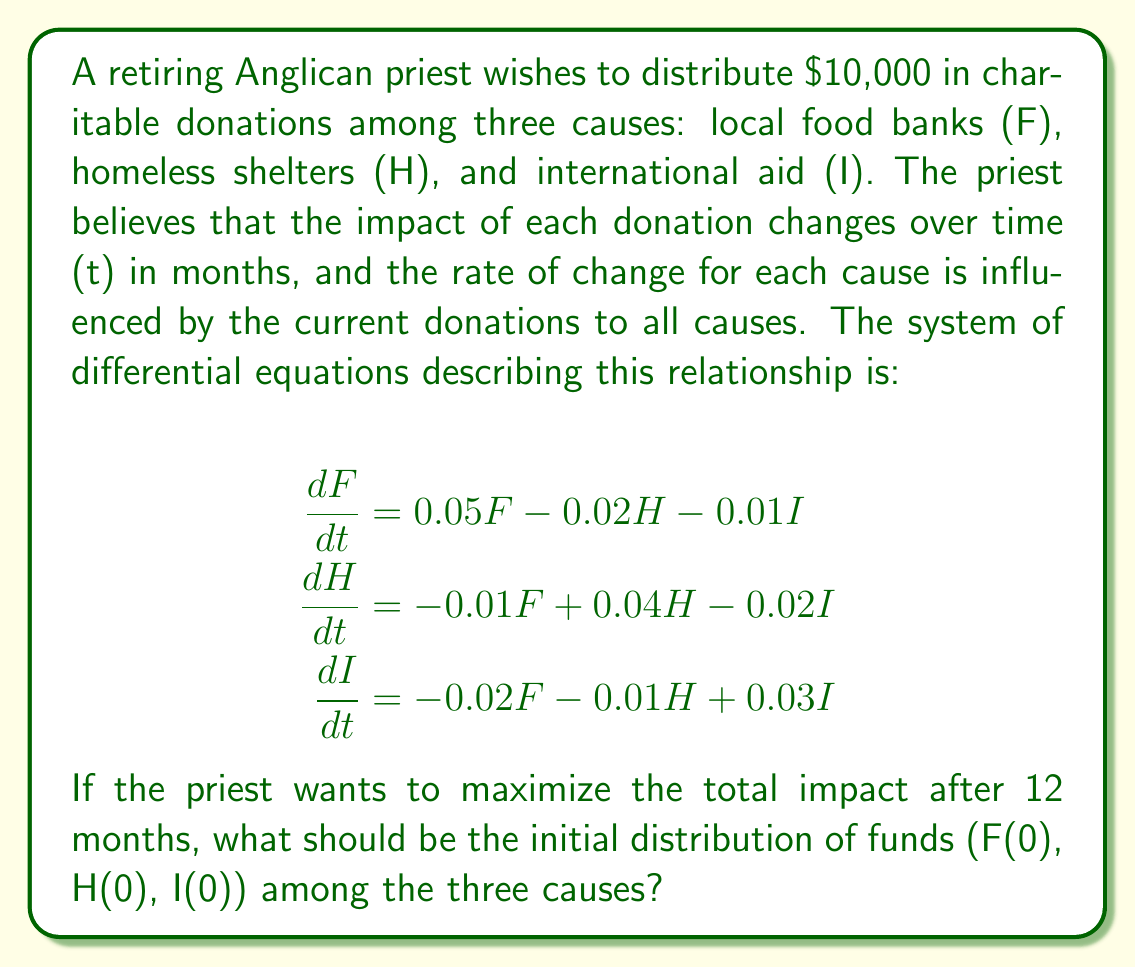Provide a solution to this math problem. To solve this problem, we need to follow these steps:

1) First, we recognize that this is a linear system of differential equations. The general solution for such a system is a linear combination of exponential functions.

2) We need to find the eigenvalues and eigenvectors of the coefficient matrix:

   $$A = \begin{bmatrix}
   0.05 & -0.02 & -0.01 \\
   -0.01 & 0.04 & -0.02 \\
   -0.02 & -0.01 & 0.03
   \end{bmatrix}$$

3) The characteristic equation is:
   
   $$det(A - \lambda I) = 0$$
   
   $$\begin{vmatrix}
   0.05-\lambda & -0.02 & -0.01 \\
   -0.01 & 0.04-\lambda & -0.02 \\
   -0.02 & -0.01 & 0.03-\lambda
   \end{vmatrix} = 0$$

4) Solving this equation gives us the eigenvalues:
   
   $\lambda_1 \approx 0.0859$, $\lambda_2 \approx 0.0256$, $\lambda_3 \approx -0.0115$

5) For each eigenvalue, we find the corresponding eigenvector. Let's call these $v_1$, $v_2$, and $v_3$.

6) The general solution is of the form:

   $$\begin{bmatrix} F(t) \\ H(t) \\ I(t) \end{bmatrix} = c_1e^{\lambda_1t}v_1 + c_2e^{\lambda_2t}v_2 + c_3e^{\lambda_3t}v_3$$

7) To maximize the total impact after 12 months, we want to maximize $F(12) + H(12) + I(12)$.

8) Given the positive eigenvalues $\lambda_1$ and $\lambda_2$, the terms with these eigenvalues will grow over time, while the term with $\lambda_3$ will decay.

9) Therefore, to maximize the total impact, we should allocate all the funds to the cause corresponding to the largest positive eigenvalue, which is $\lambda_1$.

10) The eigenvector corresponding to $\lambda_1$ is approximately:

    $$v_1 \approx \begin{bmatrix} 0.7071 \\ 0.5774 \\ 0.4082 \end{bmatrix}$$

11) Normalizing this vector to sum to 10,000, we get the optimal initial distribution.
Answer: The optimal initial distribution of funds to maximize total impact after 12 months is approximately:

F(0) ≈ $4,183
H(0) ≈ $3,415
I(0) ≈ $2,402 